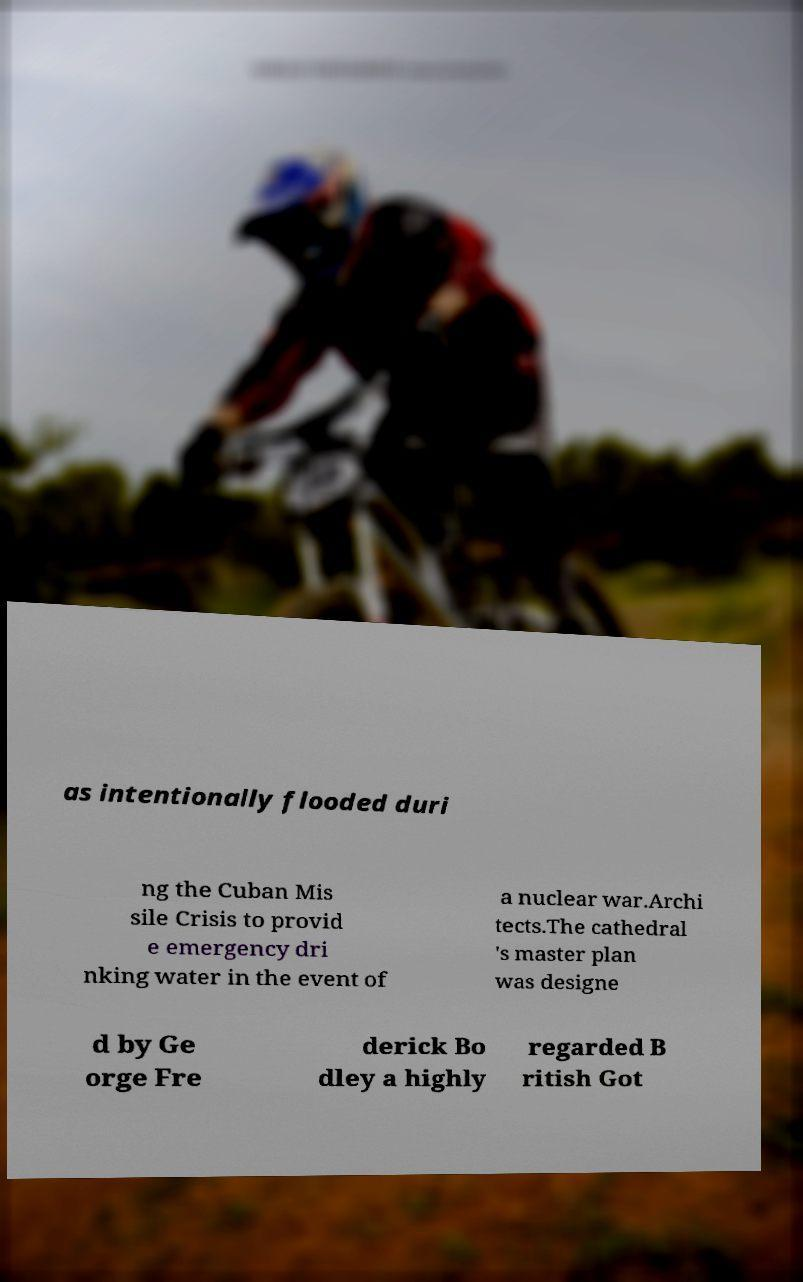Please identify and transcribe the text found in this image. as intentionally flooded duri ng the Cuban Mis sile Crisis to provid e emergency dri nking water in the event of a nuclear war.Archi tects.The cathedral 's master plan was designe d by Ge orge Fre derick Bo dley a highly regarded B ritish Got 